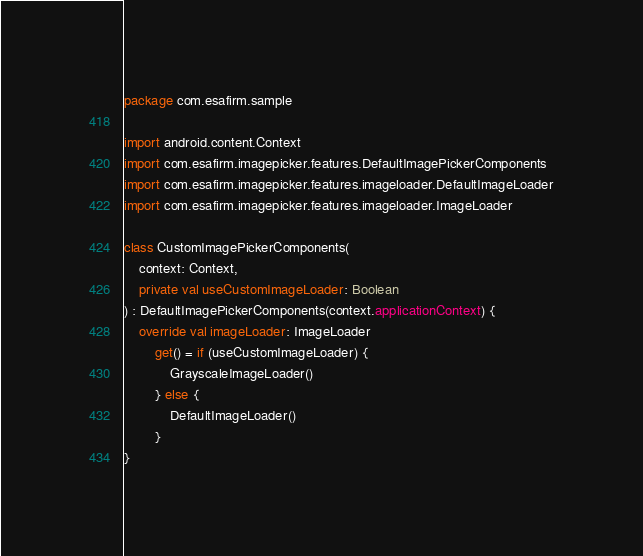Convert code to text. <code><loc_0><loc_0><loc_500><loc_500><_Kotlin_>package com.esafirm.sample

import android.content.Context
import com.esafirm.imagepicker.features.DefaultImagePickerComponents
import com.esafirm.imagepicker.features.imageloader.DefaultImageLoader
import com.esafirm.imagepicker.features.imageloader.ImageLoader

class CustomImagePickerComponents(
    context: Context,
    private val useCustomImageLoader: Boolean
) : DefaultImagePickerComponents(context.applicationContext) {
    override val imageLoader: ImageLoader
        get() = if (useCustomImageLoader) {
            GrayscaleImageLoader()
        } else {
            DefaultImageLoader()
        }
}</code> 